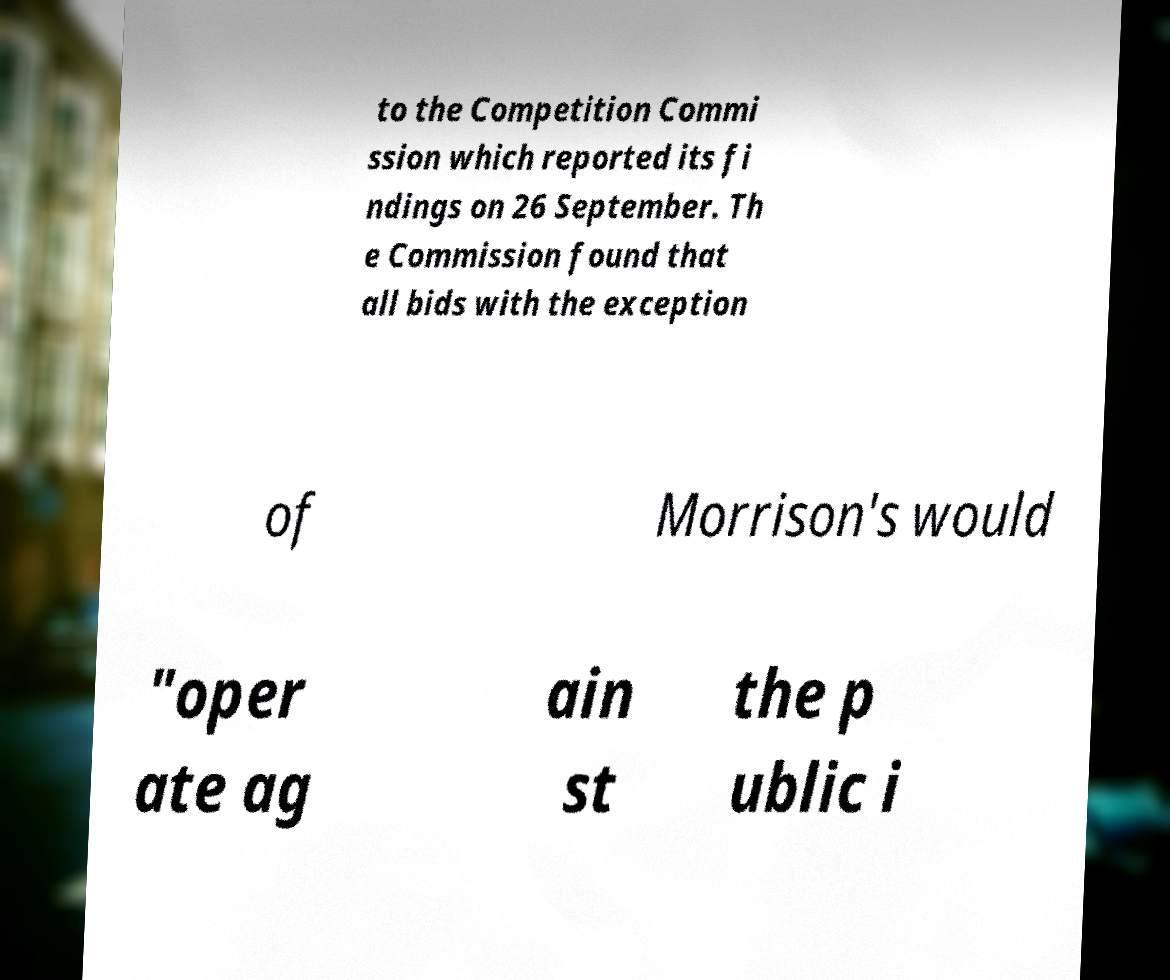For documentation purposes, I need the text within this image transcribed. Could you provide that? to the Competition Commi ssion which reported its fi ndings on 26 September. Th e Commission found that all bids with the exception of Morrison's would "oper ate ag ain st the p ublic i 